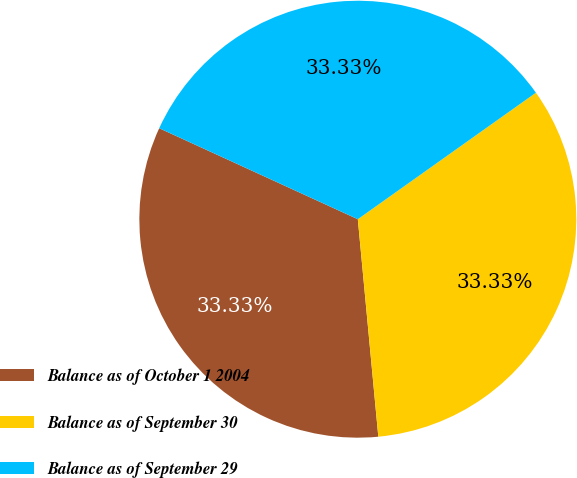Convert chart. <chart><loc_0><loc_0><loc_500><loc_500><pie_chart><fcel>Balance as of October 1 2004<fcel>Balance as of September 30<fcel>Balance as of September 29<nl><fcel>33.33%<fcel>33.33%<fcel>33.33%<nl></chart> 